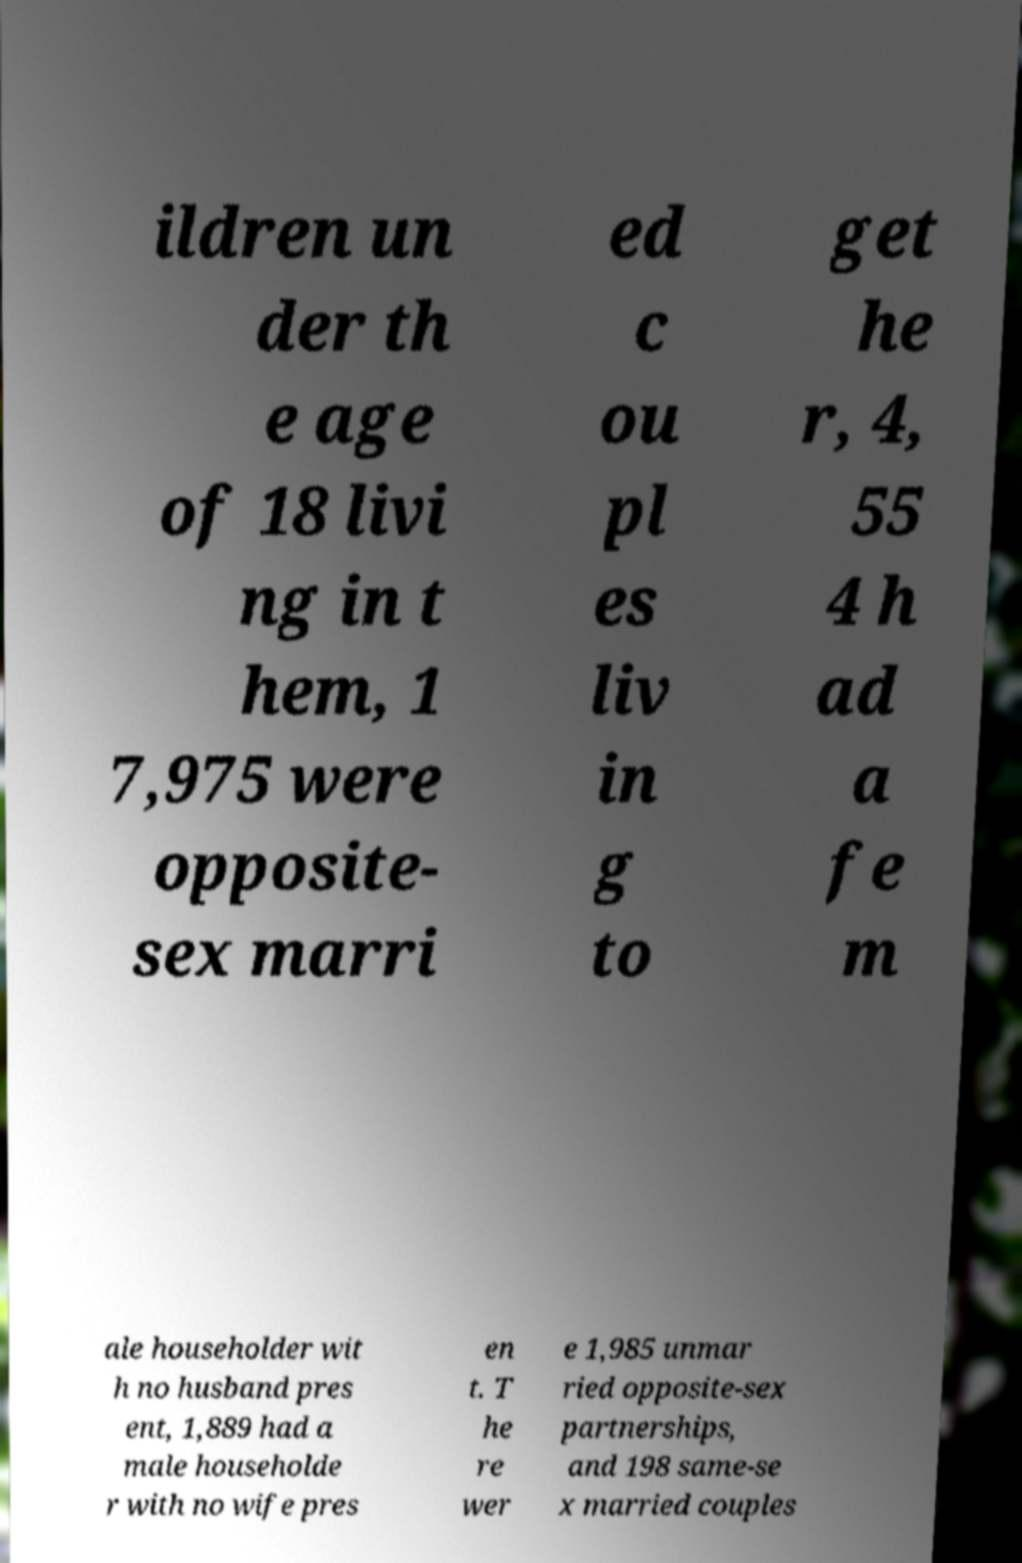For documentation purposes, I need the text within this image transcribed. Could you provide that? ildren un der th e age of 18 livi ng in t hem, 1 7,975 were opposite- sex marri ed c ou pl es liv in g to get he r, 4, 55 4 h ad a fe m ale householder wit h no husband pres ent, 1,889 had a male householde r with no wife pres en t. T he re wer e 1,985 unmar ried opposite-sex partnerships, and 198 same-se x married couples 